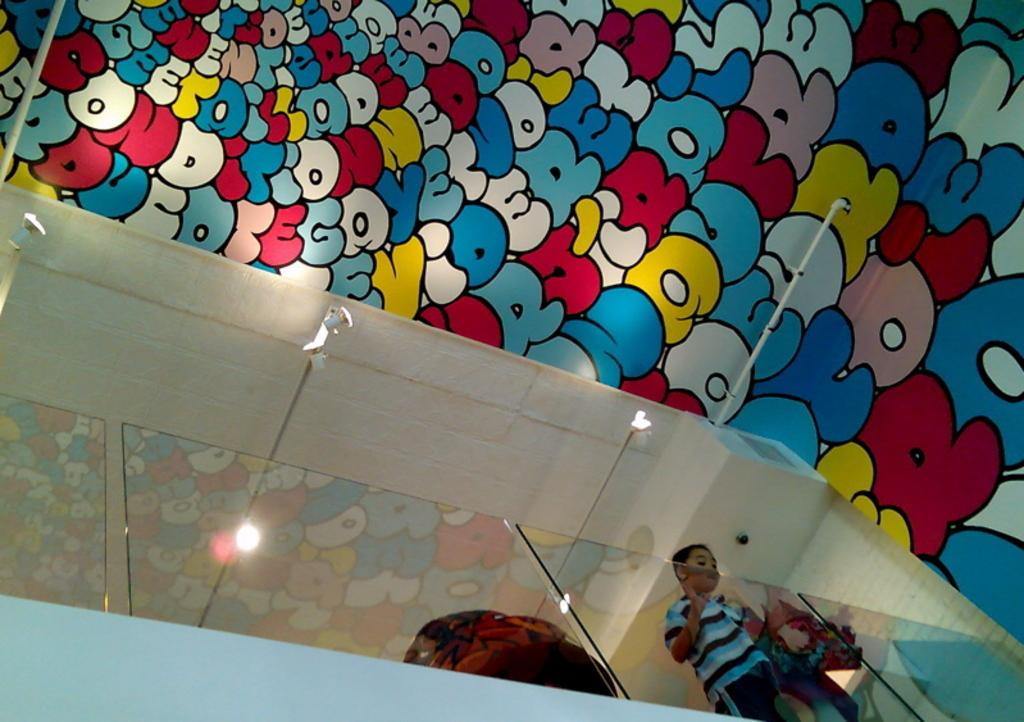What is the main subject of the image? There is a boy standing in the image. What material is present in the image? There is glass in the image. What structure can be seen in the image? There is a roof in the image. How many houses are visible in the image? There is no mention of houses in the image, so it is impossible to determine their number. 